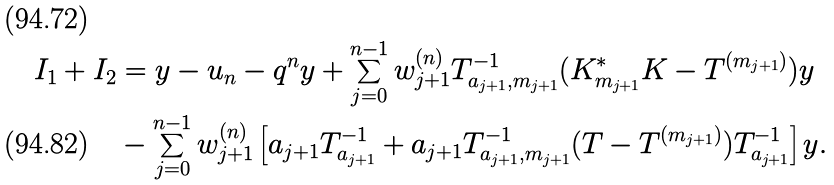Convert formula to latex. <formula><loc_0><loc_0><loc_500><loc_500>I _ { 1 } + I _ { 2 } & = y - u _ { n } - q ^ { n } y + \sum _ { j = 0 } ^ { n - 1 } w _ { j + 1 } ^ { ( n ) } T _ { a _ { j + 1 } , m _ { j + 1 } } ^ { - 1 } ( K _ { m _ { j + 1 } } ^ { * } K - T ^ { ( m _ { j + 1 } ) } ) y \\ & - \sum _ { j = 0 } ^ { n - 1 } w _ { j + 1 } ^ { ( n ) } \left [ a _ { j + 1 } T _ { a _ { j + 1 } } ^ { - 1 } + a _ { j + 1 } T _ { a _ { j + 1 } , m _ { j + 1 } } ^ { - 1 } ( T - T ^ { ( m _ { j + 1 } ) } ) T _ { a _ { j + 1 } } ^ { - 1 } \right ] y .</formula> 